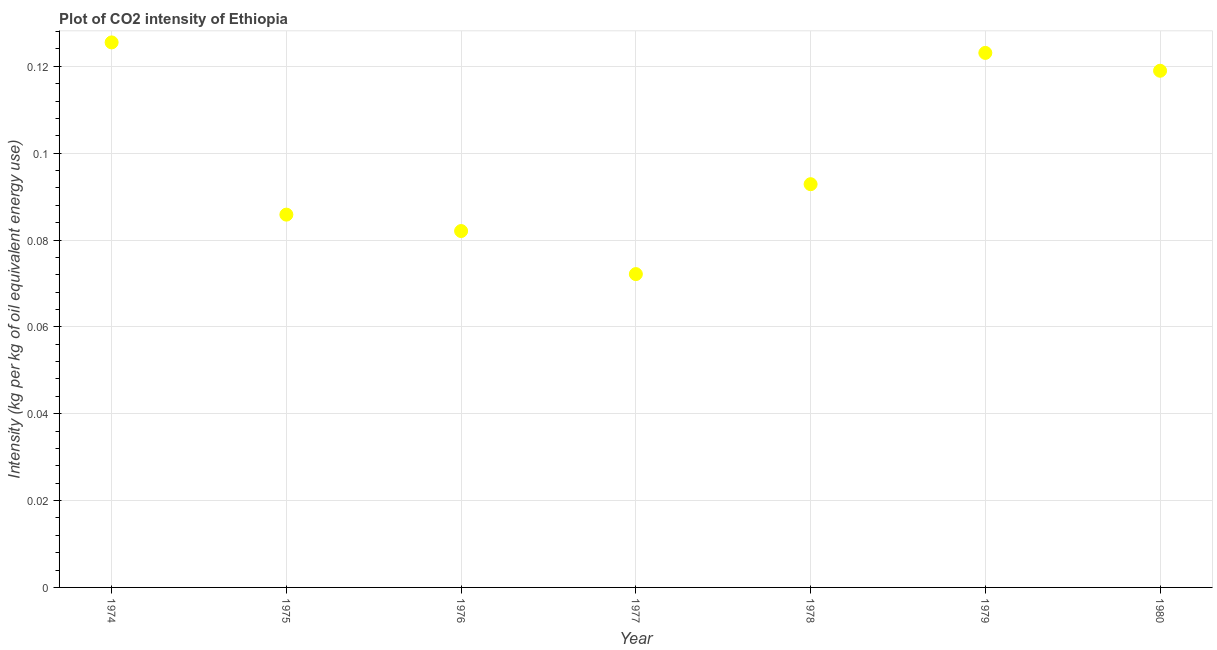What is the co2 intensity in 1976?
Provide a short and direct response. 0.08. Across all years, what is the maximum co2 intensity?
Your answer should be very brief. 0.13. Across all years, what is the minimum co2 intensity?
Your answer should be very brief. 0.07. In which year was the co2 intensity maximum?
Offer a terse response. 1974. What is the sum of the co2 intensity?
Make the answer very short. 0.7. What is the difference between the co2 intensity in 1976 and 1978?
Ensure brevity in your answer.  -0.01. What is the average co2 intensity per year?
Provide a succinct answer. 0.1. What is the median co2 intensity?
Give a very brief answer. 0.09. What is the ratio of the co2 intensity in 1975 to that in 1977?
Offer a terse response. 1.19. What is the difference between the highest and the second highest co2 intensity?
Ensure brevity in your answer.  0. What is the difference between the highest and the lowest co2 intensity?
Ensure brevity in your answer.  0.05. Does the co2 intensity monotonically increase over the years?
Keep it short and to the point. No. How many dotlines are there?
Your response must be concise. 1. What is the difference between two consecutive major ticks on the Y-axis?
Provide a succinct answer. 0.02. Does the graph contain any zero values?
Keep it short and to the point. No. What is the title of the graph?
Your answer should be very brief. Plot of CO2 intensity of Ethiopia. What is the label or title of the X-axis?
Your response must be concise. Year. What is the label or title of the Y-axis?
Offer a very short reply. Intensity (kg per kg of oil equivalent energy use). What is the Intensity (kg per kg of oil equivalent energy use) in 1974?
Make the answer very short. 0.13. What is the Intensity (kg per kg of oil equivalent energy use) in 1975?
Make the answer very short. 0.09. What is the Intensity (kg per kg of oil equivalent energy use) in 1976?
Provide a succinct answer. 0.08. What is the Intensity (kg per kg of oil equivalent energy use) in 1977?
Your response must be concise. 0.07. What is the Intensity (kg per kg of oil equivalent energy use) in 1978?
Keep it short and to the point. 0.09. What is the Intensity (kg per kg of oil equivalent energy use) in 1979?
Provide a succinct answer. 0.12. What is the Intensity (kg per kg of oil equivalent energy use) in 1980?
Offer a very short reply. 0.12. What is the difference between the Intensity (kg per kg of oil equivalent energy use) in 1974 and 1975?
Offer a very short reply. 0.04. What is the difference between the Intensity (kg per kg of oil equivalent energy use) in 1974 and 1976?
Give a very brief answer. 0.04. What is the difference between the Intensity (kg per kg of oil equivalent energy use) in 1974 and 1977?
Offer a terse response. 0.05. What is the difference between the Intensity (kg per kg of oil equivalent energy use) in 1974 and 1978?
Your response must be concise. 0.03. What is the difference between the Intensity (kg per kg of oil equivalent energy use) in 1974 and 1979?
Offer a terse response. 0. What is the difference between the Intensity (kg per kg of oil equivalent energy use) in 1974 and 1980?
Provide a succinct answer. 0.01. What is the difference between the Intensity (kg per kg of oil equivalent energy use) in 1975 and 1976?
Offer a terse response. 0. What is the difference between the Intensity (kg per kg of oil equivalent energy use) in 1975 and 1977?
Make the answer very short. 0.01. What is the difference between the Intensity (kg per kg of oil equivalent energy use) in 1975 and 1978?
Your answer should be very brief. -0.01. What is the difference between the Intensity (kg per kg of oil equivalent energy use) in 1975 and 1979?
Offer a terse response. -0.04. What is the difference between the Intensity (kg per kg of oil equivalent energy use) in 1975 and 1980?
Your response must be concise. -0.03. What is the difference between the Intensity (kg per kg of oil equivalent energy use) in 1976 and 1977?
Your answer should be very brief. 0.01. What is the difference between the Intensity (kg per kg of oil equivalent energy use) in 1976 and 1978?
Your response must be concise. -0.01. What is the difference between the Intensity (kg per kg of oil equivalent energy use) in 1976 and 1979?
Offer a terse response. -0.04. What is the difference between the Intensity (kg per kg of oil equivalent energy use) in 1976 and 1980?
Offer a terse response. -0.04. What is the difference between the Intensity (kg per kg of oil equivalent energy use) in 1977 and 1978?
Provide a succinct answer. -0.02. What is the difference between the Intensity (kg per kg of oil equivalent energy use) in 1977 and 1979?
Provide a short and direct response. -0.05. What is the difference between the Intensity (kg per kg of oil equivalent energy use) in 1977 and 1980?
Keep it short and to the point. -0.05. What is the difference between the Intensity (kg per kg of oil equivalent energy use) in 1978 and 1979?
Your answer should be very brief. -0.03. What is the difference between the Intensity (kg per kg of oil equivalent energy use) in 1978 and 1980?
Offer a very short reply. -0.03. What is the difference between the Intensity (kg per kg of oil equivalent energy use) in 1979 and 1980?
Give a very brief answer. 0. What is the ratio of the Intensity (kg per kg of oil equivalent energy use) in 1974 to that in 1975?
Your response must be concise. 1.46. What is the ratio of the Intensity (kg per kg of oil equivalent energy use) in 1974 to that in 1976?
Offer a very short reply. 1.53. What is the ratio of the Intensity (kg per kg of oil equivalent energy use) in 1974 to that in 1977?
Offer a very short reply. 1.74. What is the ratio of the Intensity (kg per kg of oil equivalent energy use) in 1974 to that in 1978?
Your answer should be very brief. 1.35. What is the ratio of the Intensity (kg per kg of oil equivalent energy use) in 1974 to that in 1980?
Your answer should be very brief. 1.05. What is the ratio of the Intensity (kg per kg of oil equivalent energy use) in 1975 to that in 1976?
Provide a succinct answer. 1.05. What is the ratio of the Intensity (kg per kg of oil equivalent energy use) in 1975 to that in 1977?
Keep it short and to the point. 1.19. What is the ratio of the Intensity (kg per kg of oil equivalent energy use) in 1975 to that in 1978?
Provide a succinct answer. 0.93. What is the ratio of the Intensity (kg per kg of oil equivalent energy use) in 1975 to that in 1979?
Provide a short and direct response. 0.7. What is the ratio of the Intensity (kg per kg of oil equivalent energy use) in 1975 to that in 1980?
Give a very brief answer. 0.72. What is the ratio of the Intensity (kg per kg of oil equivalent energy use) in 1976 to that in 1977?
Your answer should be very brief. 1.14. What is the ratio of the Intensity (kg per kg of oil equivalent energy use) in 1976 to that in 1978?
Your answer should be very brief. 0.88. What is the ratio of the Intensity (kg per kg of oil equivalent energy use) in 1976 to that in 1979?
Keep it short and to the point. 0.67. What is the ratio of the Intensity (kg per kg of oil equivalent energy use) in 1976 to that in 1980?
Make the answer very short. 0.69. What is the ratio of the Intensity (kg per kg of oil equivalent energy use) in 1977 to that in 1978?
Offer a very short reply. 0.78. What is the ratio of the Intensity (kg per kg of oil equivalent energy use) in 1977 to that in 1979?
Make the answer very short. 0.59. What is the ratio of the Intensity (kg per kg of oil equivalent energy use) in 1977 to that in 1980?
Make the answer very short. 0.61. What is the ratio of the Intensity (kg per kg of oil equivalent energy use) in 1978 to that in 1979?
Offer a terse response. 0.75. What is the ratio of the Intensity (kg per kg of oil equivalent energy use) in 1978 to that in 1980?
Your response must be concise. 0.78. What is the ratio of the Intensity (kg per kg of oil equivalent energy use) in 1979 to that in 1980?
Offer a terse response. 1.03. 